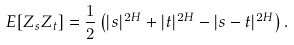<formula> <loc_0><loc_0><loc_500><loc_500>E [ Z _ { s } Z _ { t } ] & = \frac { 1 } { 2 } \left ( | s | ^ { 2 H } + | t | ^ { 2 H } - | s - t | ^ { 2 H } \right ) .</formula> 